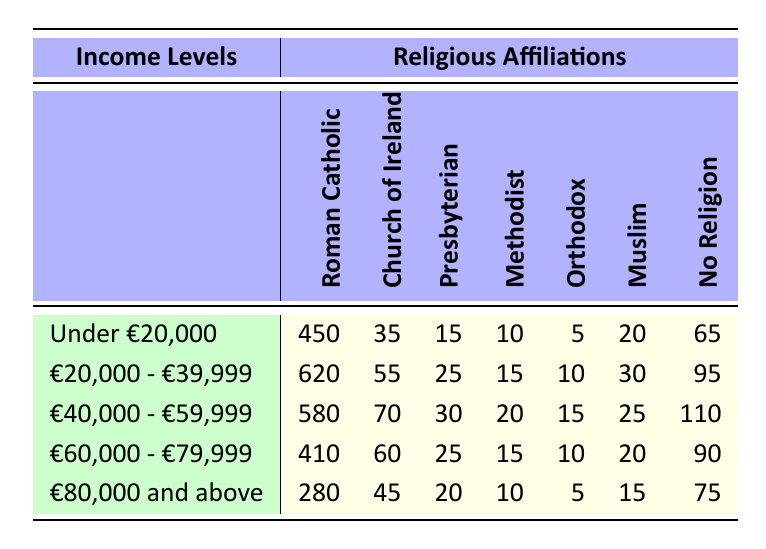What is the number of Roman Catholics in the income level "€20,000 - €39,999"? The table shows the number of Roman Catholics for the income level "€20,000 - €39,999" as 620.
Answer: 620 Which income level has the highest number of individuals with no religion? The highest number of individuals with no religion is found in the income level "€40,000 - €59,999" with 110 individuals.
Answer: €40,000 - €59,999 What is the total number of Methodists across all income levels? By summing the number of Methodists from each income level: 10 + 15 + 20 + 15 + 10 = 70.
Answer: 70 How many more Roman Catholics are there in "€20,000 - €39,999" compared to "€80,000 and above"? The difference is calculated by subtracting the number of Roman Catholics in "€80,000 and above" (280) from those in "€20,000 - €39,999" (620): 620 - 280 = 340.
Answer: 340 Is there a higher number of Muslims in the income level "€60,000 - €79,999" than in "Under €20,000"? The number of Muslims in "€60,000 - €79,999" is 20, while in "Under €20,000," it is 20 as well, therefore they are equal.
Answer: No What is the average number of Church of Ireland members across all income levels? To calculate the average, sum the numbers for Church of Ireland (35 + 55 + 70 + 60 + 45 = 265) and divide by the number of income levels (5): 265 / 5 = 53.
Answer: 53 In which income level is the count of Presbyterians the highest? The highest number of Presbyterians is found in the income level "€40,000 - €59,999" with 30 members.
Answer: €40,000 - €59,999 What percentage of "Under €20,000" individuals reported having no religion? The number of individuals with no religion in "Under €20,000" is 65, and the total for that income level is 450 + 35 + 15 + 10 + 5 + 20 + 65 = 600. The percentage is (65 / 600) * 100 = 10.83%.
Answer: 10.83% How many individuals are there in total across all income levels? Total individuals can be found by summing all individuals from each income group: 600 + 850 + 830 + 730 + 455 = 3665.
Answer: 3665 Is the number of Orthodox believers in "€80,000 and above" more than the total number of Methodists in "€20,000 - €39,999"? There are 5 Orthodox believers in "€80,000 and above" and 15 Methodists in "€20,000 - €39,999". Since 5 < 15, the statement is false.
Answer: No 